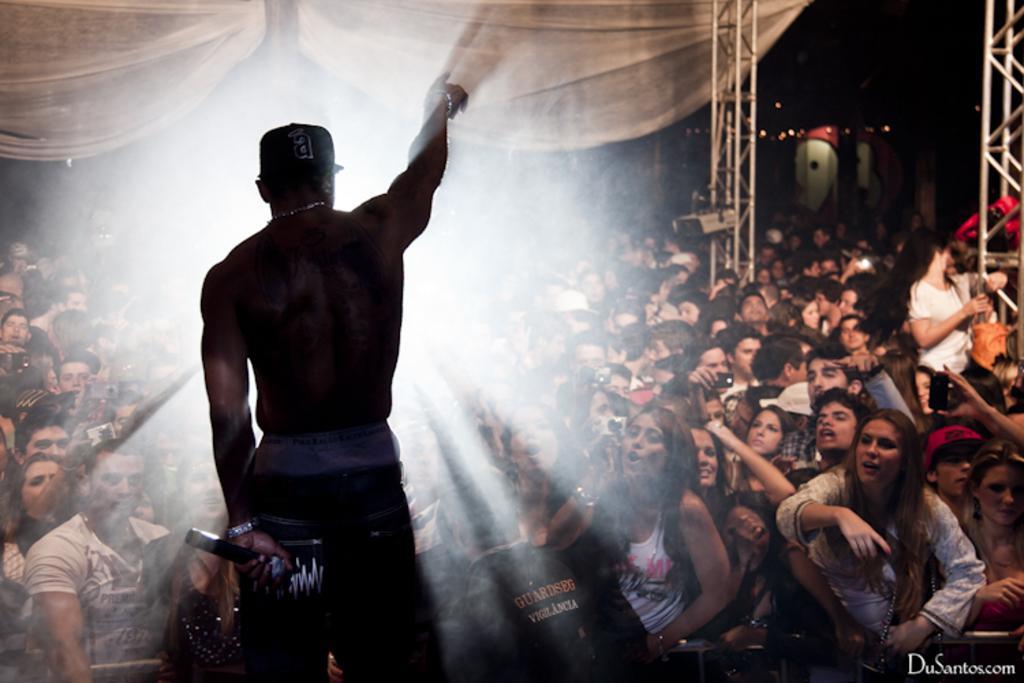Describe this image in one or two sentences. In this picture we can see a person is standing and holding a microphone in the front, in the background there are some people, we can see a cloth at the left top of the picture, there is some text at the right bottom. 